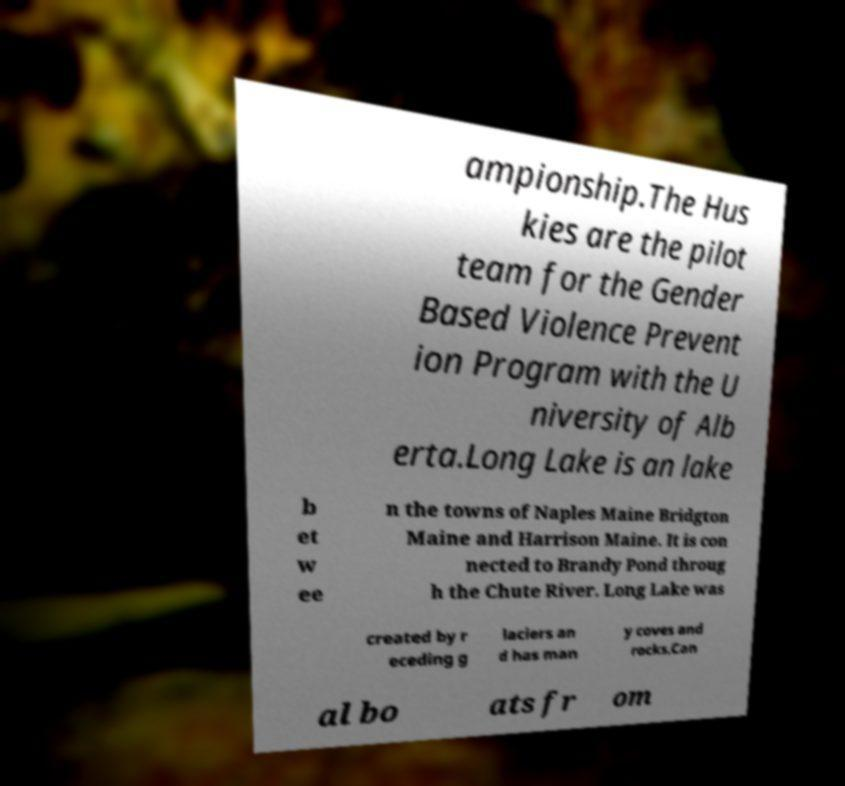Can you read and provide the text displayed in the image?This photo seems to have some interesting text. Can you extract and type it out for me? ampionship.The Hus kies are the pilot team for the Gender Based Violence Prevent ion Program with the U niversity of Alb erta.Long Lake is an lake b et w ee n the towns of Naples Maine Bridgton Maine and Harrison Maine. It is con nected to Brandy Pond throug h the Chute River. Long Lake was created by r eceding g laciers an d has man y coves and rocks.Can al bo ats fr om 